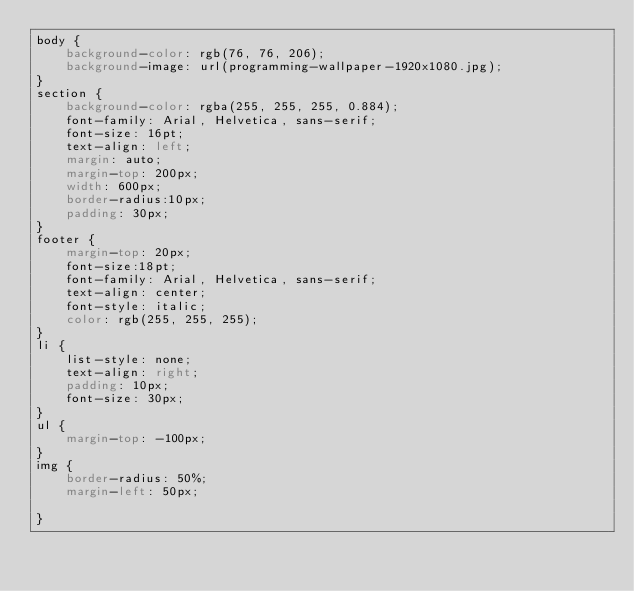Convert code to text. <code><loc_0><loc_0><loc_500><loc_500><_CSS_>body {
    background-color: rgb(76, 76, 206);
    background-image: url(programming-wallpaper-1920x1080.jpg);
}
section {
    background-color: rgba(255, 255, 255, 0.884);
    font-family: Arial, Helvetica, sans-serif;
    font-size: 16pt;
    text-align: left;
    margin: auto;
    margin-top: 200px;
    width: 600px;
    border-radius:10px;
    padding: 30px;
}
footer {
    margin-top: 20px;
    font-size:18pt;
    font-family: Arial, Helvetica, sans-serif;
    text-align: center;
    font-style: italic;
    color: rgb(255, 255, 255);
}
li {
    list-style: none;
    text-align: right;
    padding: 10px;
    font-size: 30px;
}
ul {
    margin-top: -100px;
}
img {
    border-radius: 50%;
    margin-left: 50px;

}</code> 